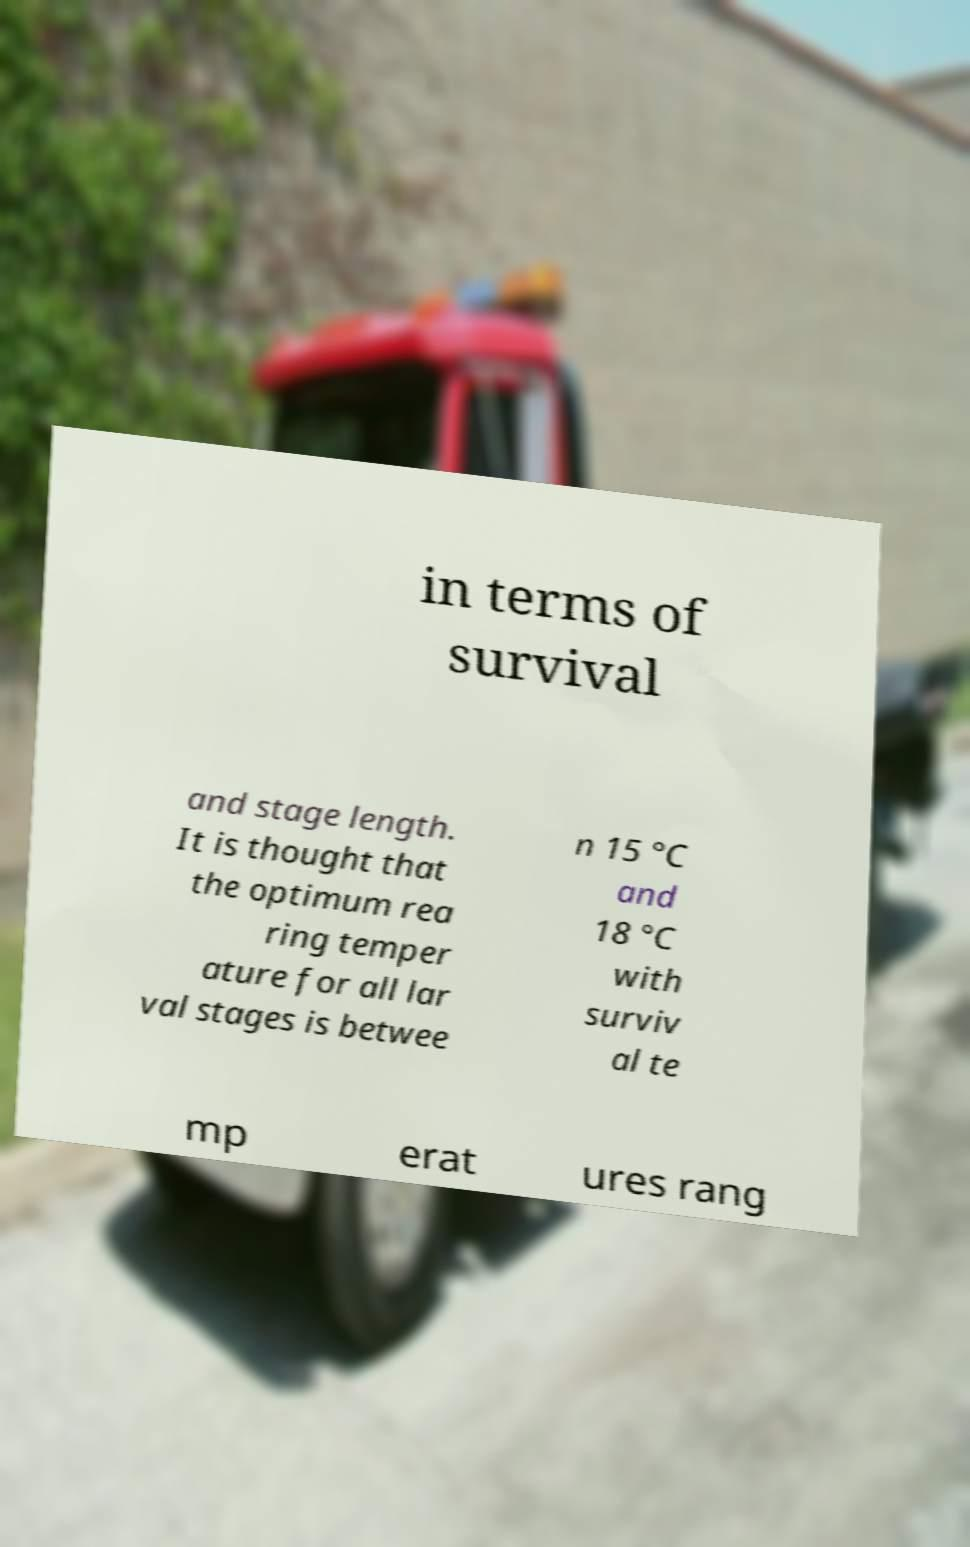Please identify and transcribe the text found in this image. in terms of survival and stage length. It is thought that the optimum rea ring temper ature for all lar val stages is betwee n 15 °C and 18 °C with surviv al te mp erat ures rang 